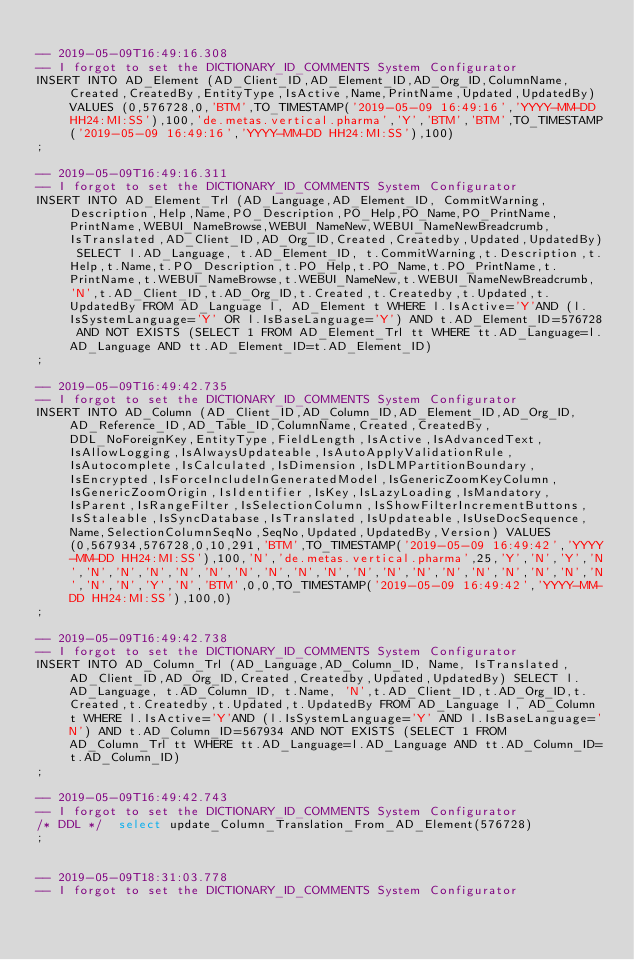Convert code to text. <code><loc_0><loc_0><loc_500><loc_500><_SQL_>
-- 2019-05-09T16:49:16.308
-- I forgot to set the DICTIONARY_ID_COMMENTS System Configurator
INSERT INTO AD_Element (AD_Client_ID,AD_Element_ID,AD_Org_ID,ColumnName,Created,CreatedBy,EntityType,IsActive,Name,PrintName,Updated,UpdatedBy) VALUES (0,576728,0,'BTM',TO_TIMESTAMP('2019-05-09 16:49:16','YYYY-MM-DD HH24:MI:SS'),100,'de.metas.vertical.pharma','Y','BTM','BTM',TO_TIMESTAMP('2019-05-09 16:49:16','YYYY-MM-DD HH24:MI:SS'),100)
;

-- 2019-05-09T16:49:16.311
-- I forgot to set the DICTIONARY_ID_COMMENTS System Configurator
INSERT INTO AD_Element_Trl (AD_Language,AD_Element_ID, CommitWarning,Description,Help,Name,PO_Description,PO_Help,PO_Name,PO_PrintName,PrintName,WEBUI_NameBrowse,WEBUI_NameNew,WEBUI_NameNewBreadcrumb, IsTranslated,AD_Client_ID,AD_Org_ID,Created,Createdby,Updated,UpdatedBy) SELECT l.AD_Language, t.AD_Element_ID, t.CommitWarning,t.Description,t.Help,t.Name,t.PO_Description,t.PO_Help,t.PO_Name,t.PO_PrintName,t.PrintName,t.WEBUI_NameBrowse,t.WEBUI_NameNew,t.WEBUI_NameNewBreadcrumb, 'N',t.AD_Client_ID,t.AD_Org_ID,t.Created,t.Createdby,t.Updated,t.UpdatedBy FROM AD_Language l, AD_Element t WHERE l.IsActive='Y'AND (l.IsSystemLanguage='Y' OR l.IsBaseLanguage='Y') AND t.AD_Element_ID=576728 AND NOT EXISTS (SELECT 1 FROM AD_Element_Trl tt WHERE tt.AD_Language=l.AD_Language AND tt.AD_Element_ID=t.AD_Element_ID)
;

-- 2019-05-09T16:49:42.735
-- I forgot to set the DICTIONARY_ID_COMMENTS System Configurator
INSERT INTO AD_Column (AD_Client_ID,AD_Column_ID,AD_Element_ID,AD_Org_ID,AD_Reference_ID,AD_Table_ID,ColumnName,Created,CreatedBy,DDL_NoForeignKey,EntityType,FieldLength,IsActive,IsAdvancedText,IsAllowLogging,IsAlwaysUpdateable,IsAutoApplyValidationRule,IsAutocomplete,IsCalculated,IsDimension,IsDLMPartitionBoundary,IsEncrypted,IsForceIncludeInGeneratedModel,IsGenericZoomKeyColumn,IsGenericZoomOrigin,IsIdentifier,IsKey,IsLazyLoading,IsMandatory,IsParent,IsRangeFilter,IsSelectionColumn,IsShowFilterIncrementButtons,IsStaleable,IsSyncDatabase,IsTranslated,IsUpdateable,IsUseDocSequence,Name,SelectionColumnSeqNo,SeqNo,Updated,UpdatedBy,Version) VALUES (0,567934,576728,0,10,291,'BTM',TO_TIMESTAMP('2019-05-09 16:49:42','YYYY-MM-DD HH24:MI:SS'),100,'N','de.metas.vertical.pharma',25,'Y','N','Y','N','N','N','N','N','N','N','N','N','N','N','N','N','N','N','N','N','N','N','N','N','Y','N','BTM',0,0,TO_TIMESTAMP('2019-05-09 16:49:42','YYYY-MM-DD HH24:MI:SS'),100,0)
;

-- 2019-05-09T16:49:42.738
-- I forgot to set the DICTIONARY_ID_COMMENTS System Configurator
INSERT INTO AD_Column_Trl (AD_Language,AD_Column_ID, Name, IsTranslated,AD_Client_ID,AD_Org_ID,Created,Createdby,Updated,UpdatedBy) SELECT l.AD_Language, t.AD_Column_ID, t.Name, 'N',t.AD_Client_ID,t.AD_Org_ID,t.Created,t.Createdby,t.Updated,t.UpdatedBy FROM AD_Language l, AD_Column t WHERE l.IsActive='Y'AND (l.IsSystemLanguage='Y' AND l.IsBaseLanguage='N') AND t.AD_Column_ID=567934 AND NOT EXISTS (SELECT 1 FROM AD_Column_Trl tt WHERE tt.AD_Language=l.AD_Language AND tt.AD_Column_ID=t.AD_Column_ID)
;

-- 2019-05-09T16:49:42.743
-- I forgot to set the DICTIONARY_ID_COMMENTS System Configurator
/* DDL */  select update_Column_Translation_From_AD_Element(576728) 
;


-- 2019-05-09T18:31:03.778
-- I forgot to set the DICTIONARY_ID_COMMENTS System Configurator</code> 